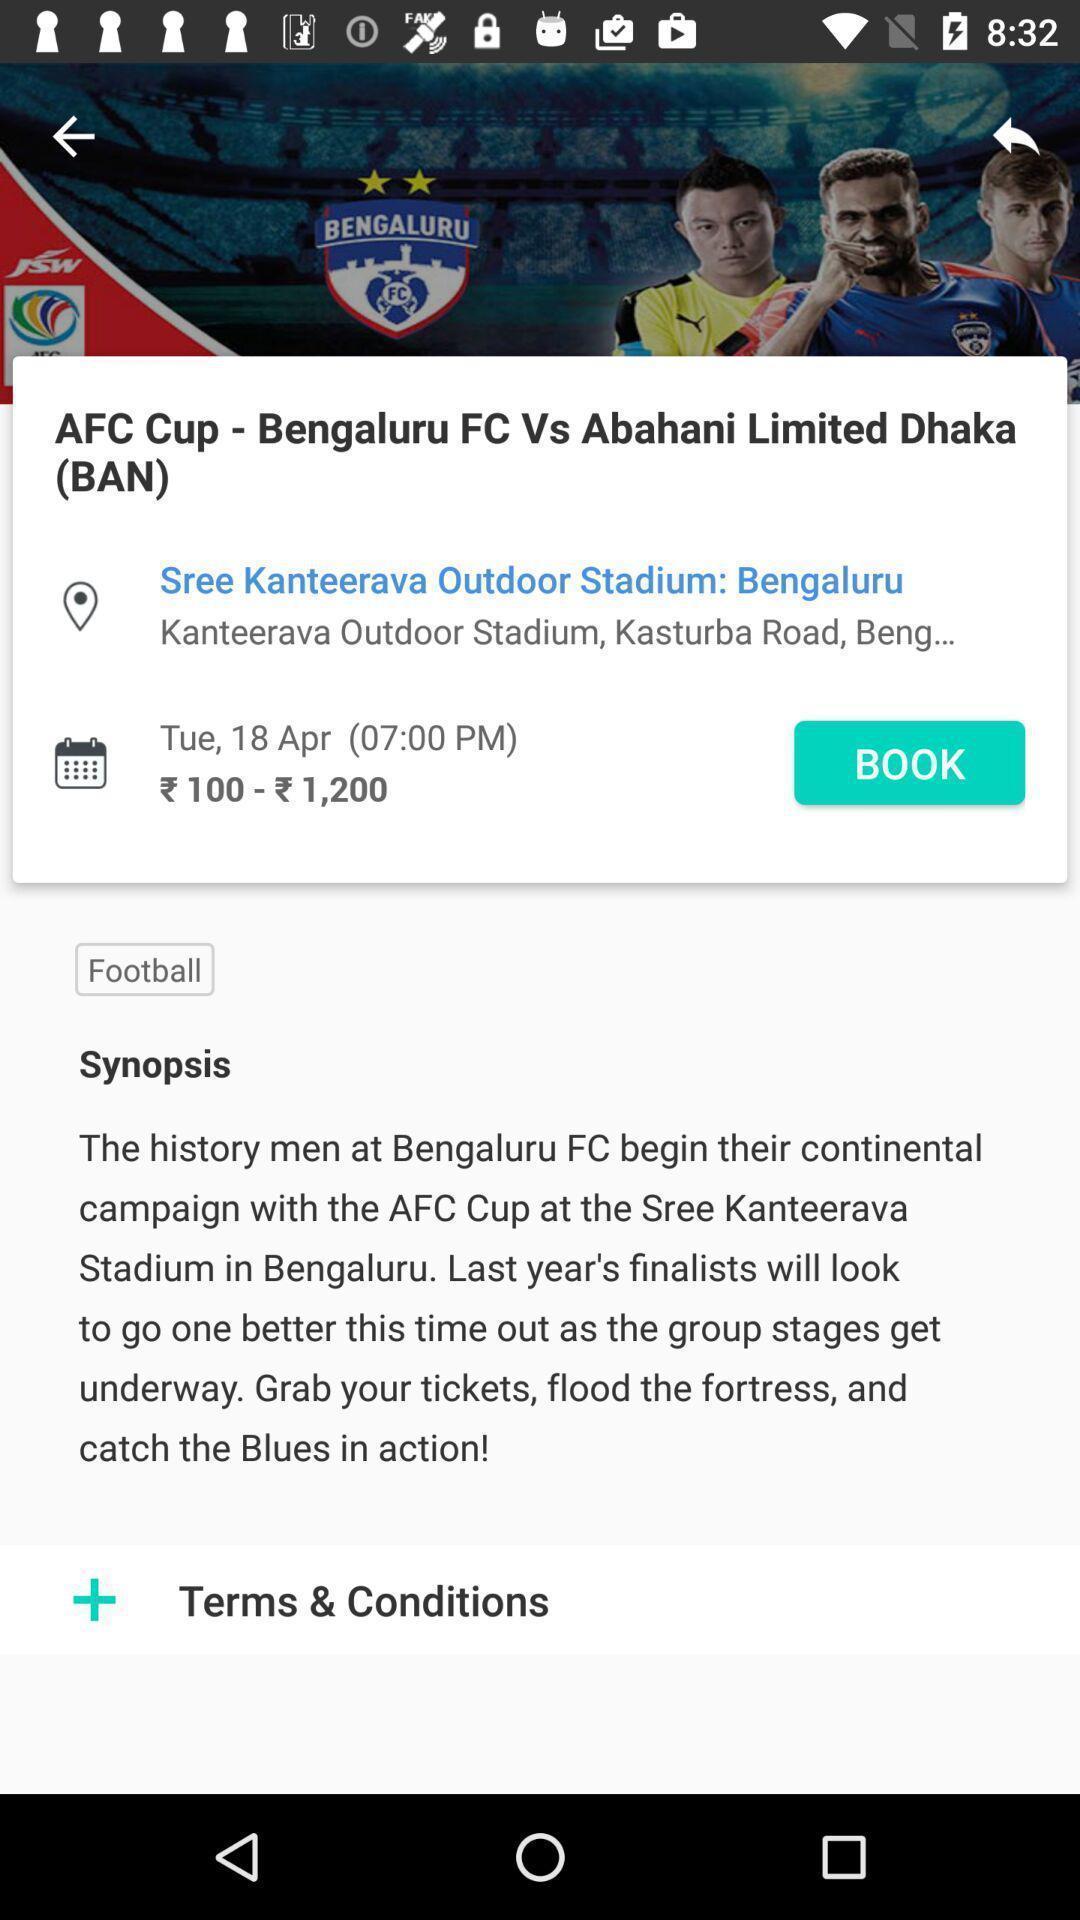Describe the key features of this screenshot. Page showing details of an upcoming sports match. 